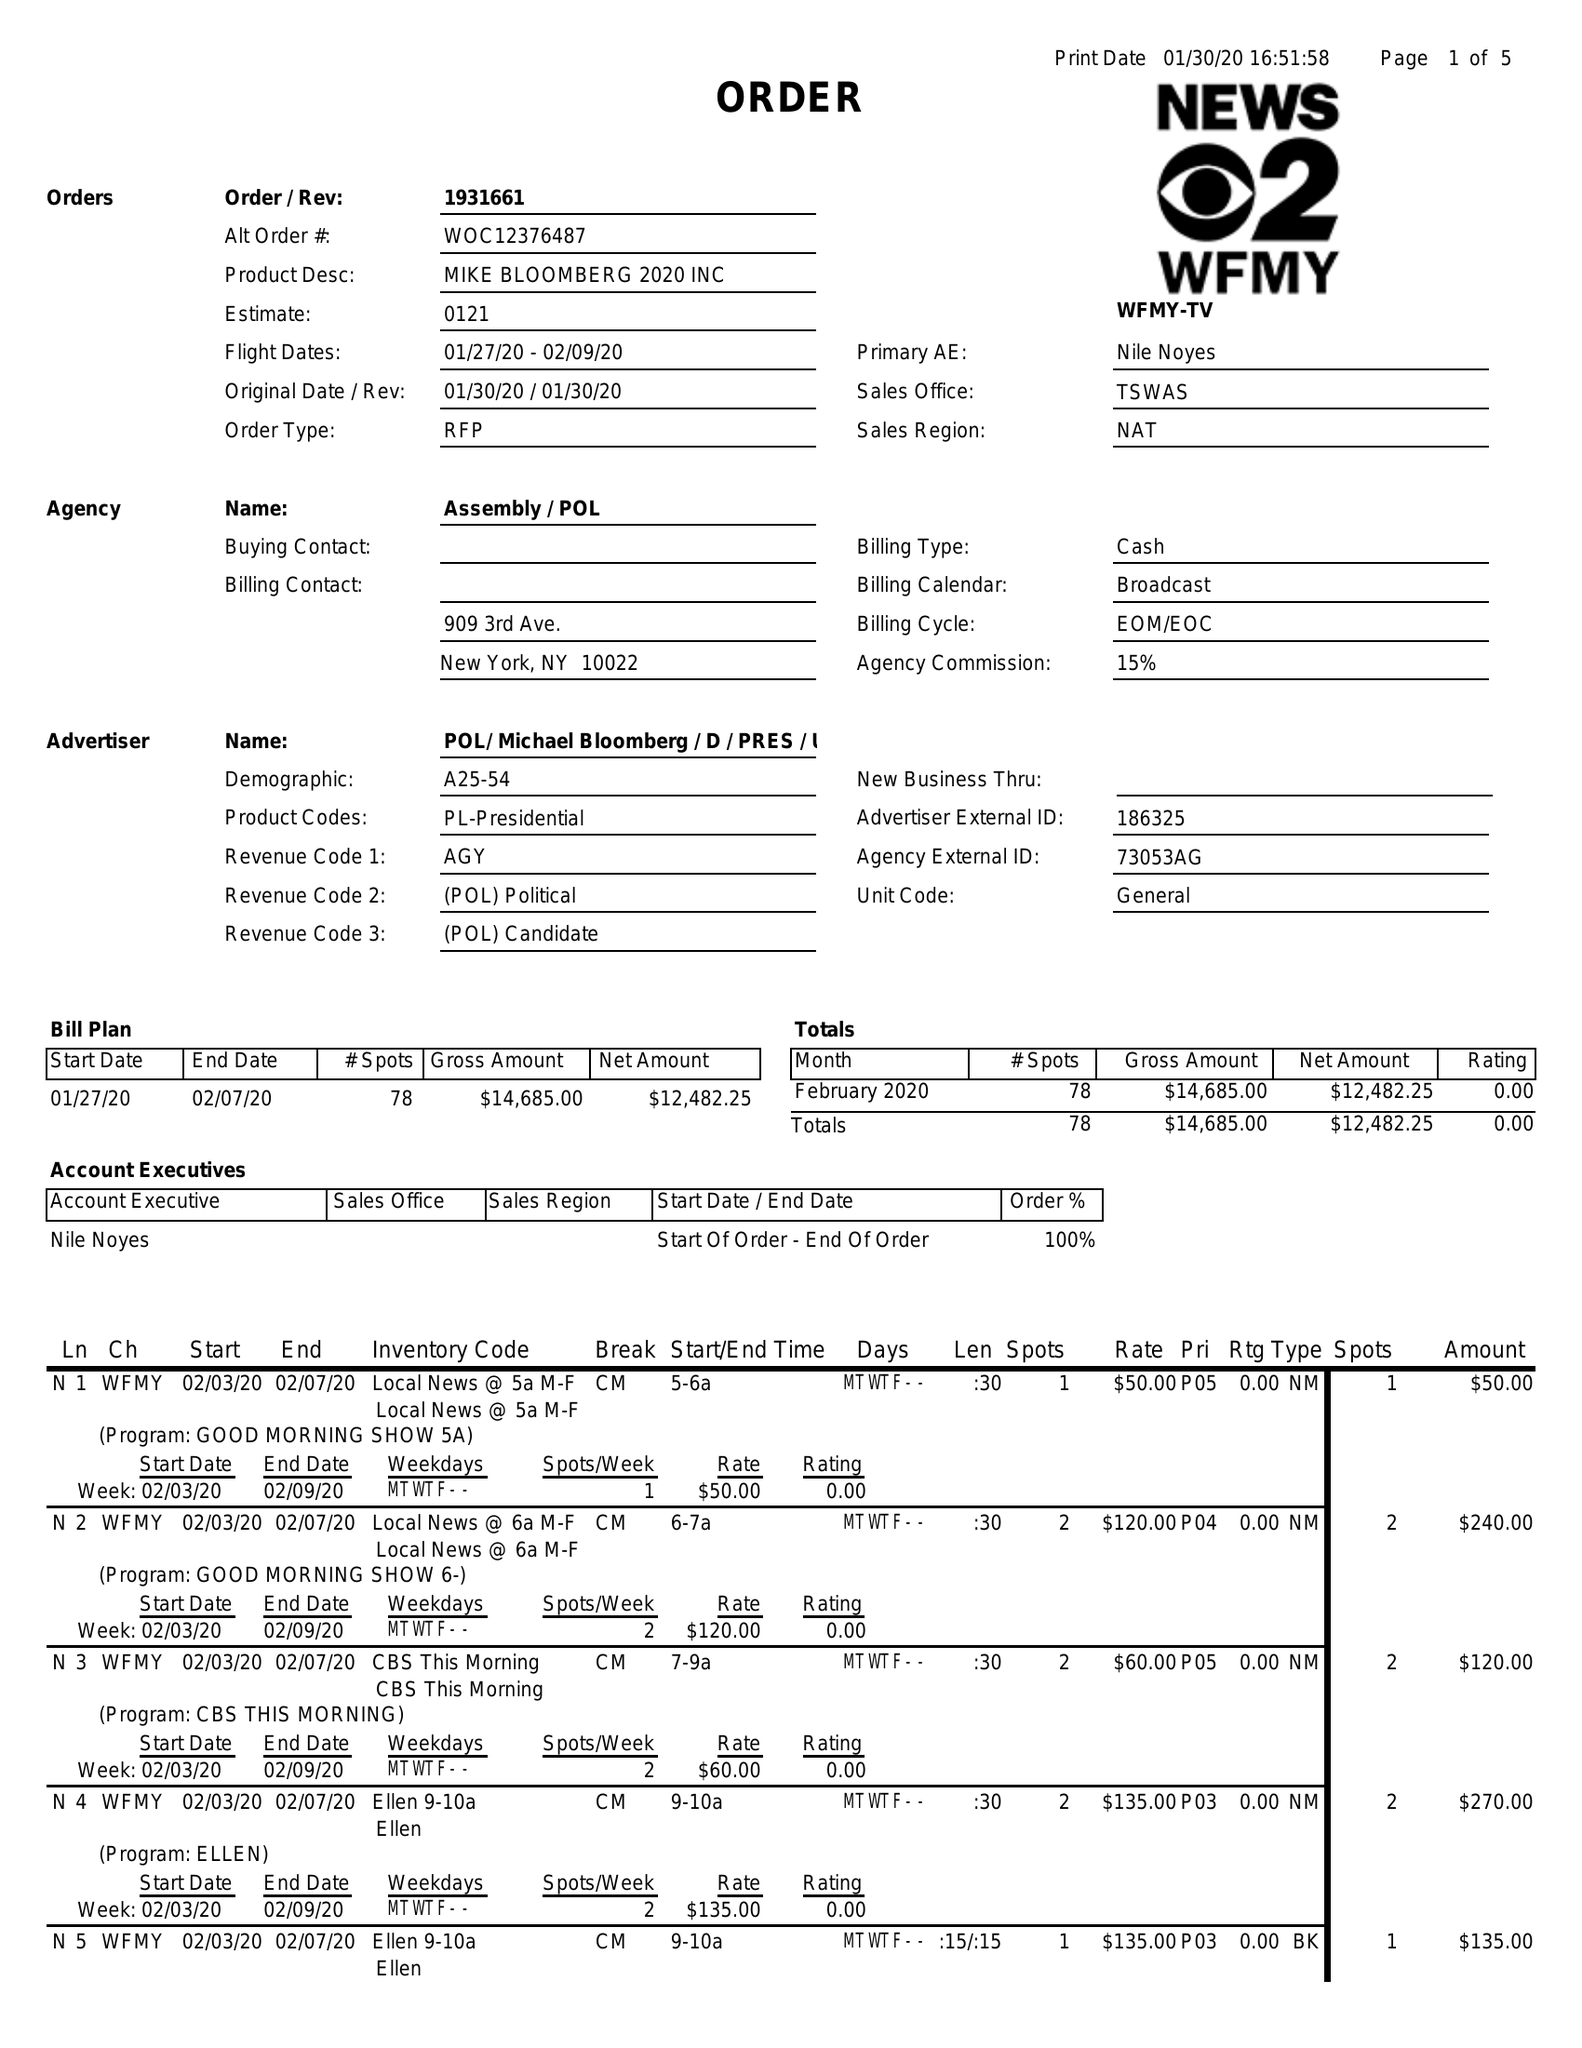What is the value for the contract_num?
Answer the question using a single word or phrase. 1931661 